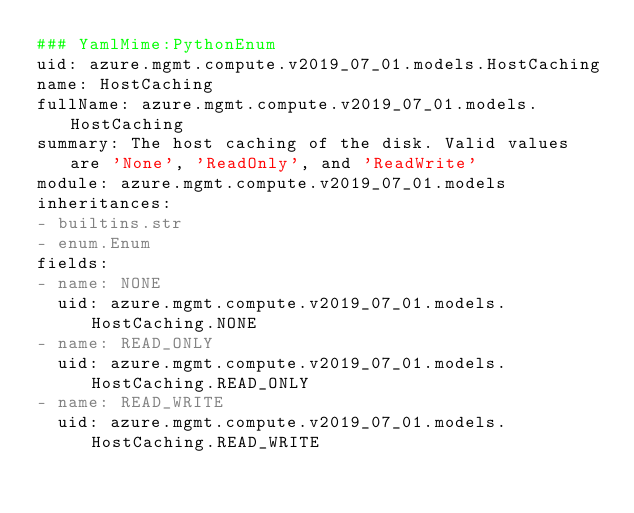Convert code to text. <code><loc_0><loc_0><loc_500><loc_500><_YAML_>### YamlMime:PythonEnum
uid: azure.mgmt.compute.v2019_07_01.models.HostCaching
name: HostCaching
fullName: azure.mgmt.compute.v2019_07_01.models.HostCaching
summary: The host caching of the disk. Valid values are 'None', 'ReadOnly', and 'ReadWrite'
module: azure.mgmt.compute.v2019_07_01.models
inheritances:
- builtins.str
- enum.Enum
fields:
- name: NONE
  uid: azure.mgmt.compute.v2019_07_01.models.HostCaching.NONE
- name: READ_ONLY
  uid: azure.mgmt.compute.v2019_07_01.models.HostCaching.READ_ONLY
- name: READ_WRITE
  uid: azure.mgmt.compute.v2019_07_01.models.HostCaching.READ_WRITE
</code> 